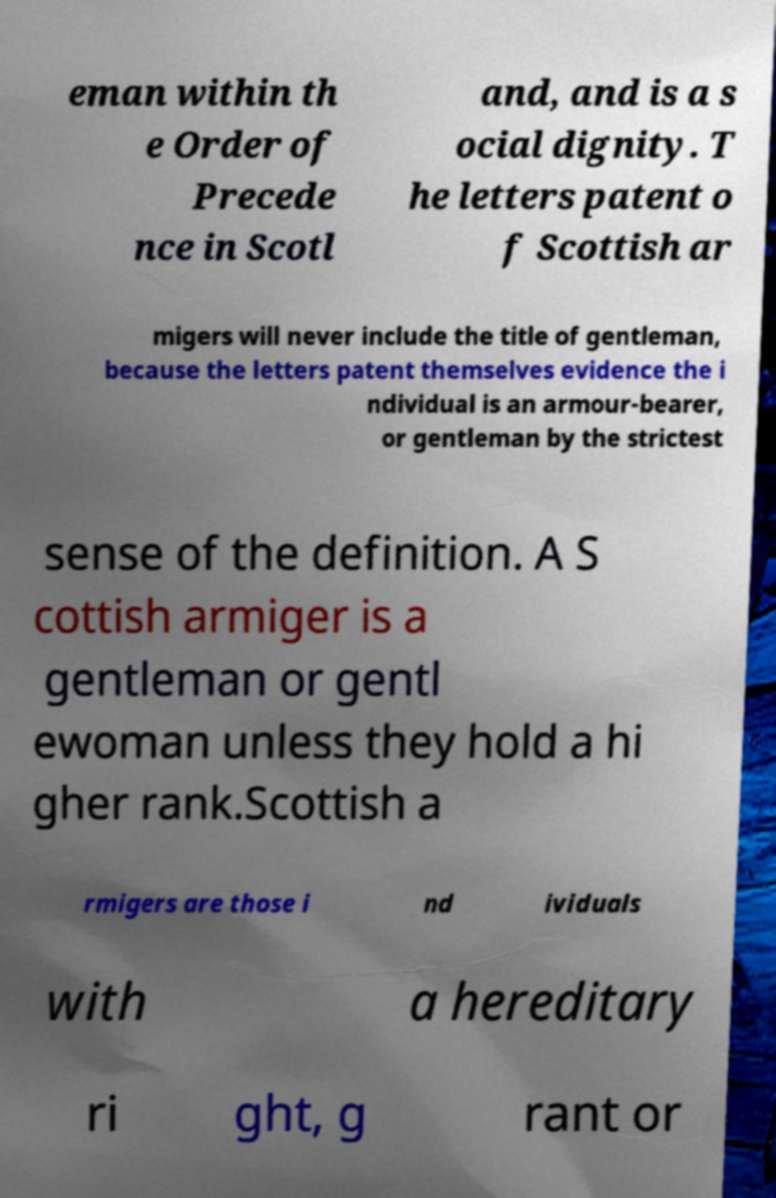There's text embedded in this image that I need extracted. Can you transcribe it verbatim? eman within th e Order of Precede nce in Scotl and, and is a s ocial dignity. T he letters patent o f Scottish ar migers will never include the title of gentleman, because the letters patent themselves evidence the i ndividual is an armour-bearer, or gentleman by the strictest sense of the definition. A S cottish armiger is a gentleman or gentl ewoman unless they hold a hi gher rank.Scottish a rmigers are those i nd ividuals with a hereditary ri ght, g rant or 